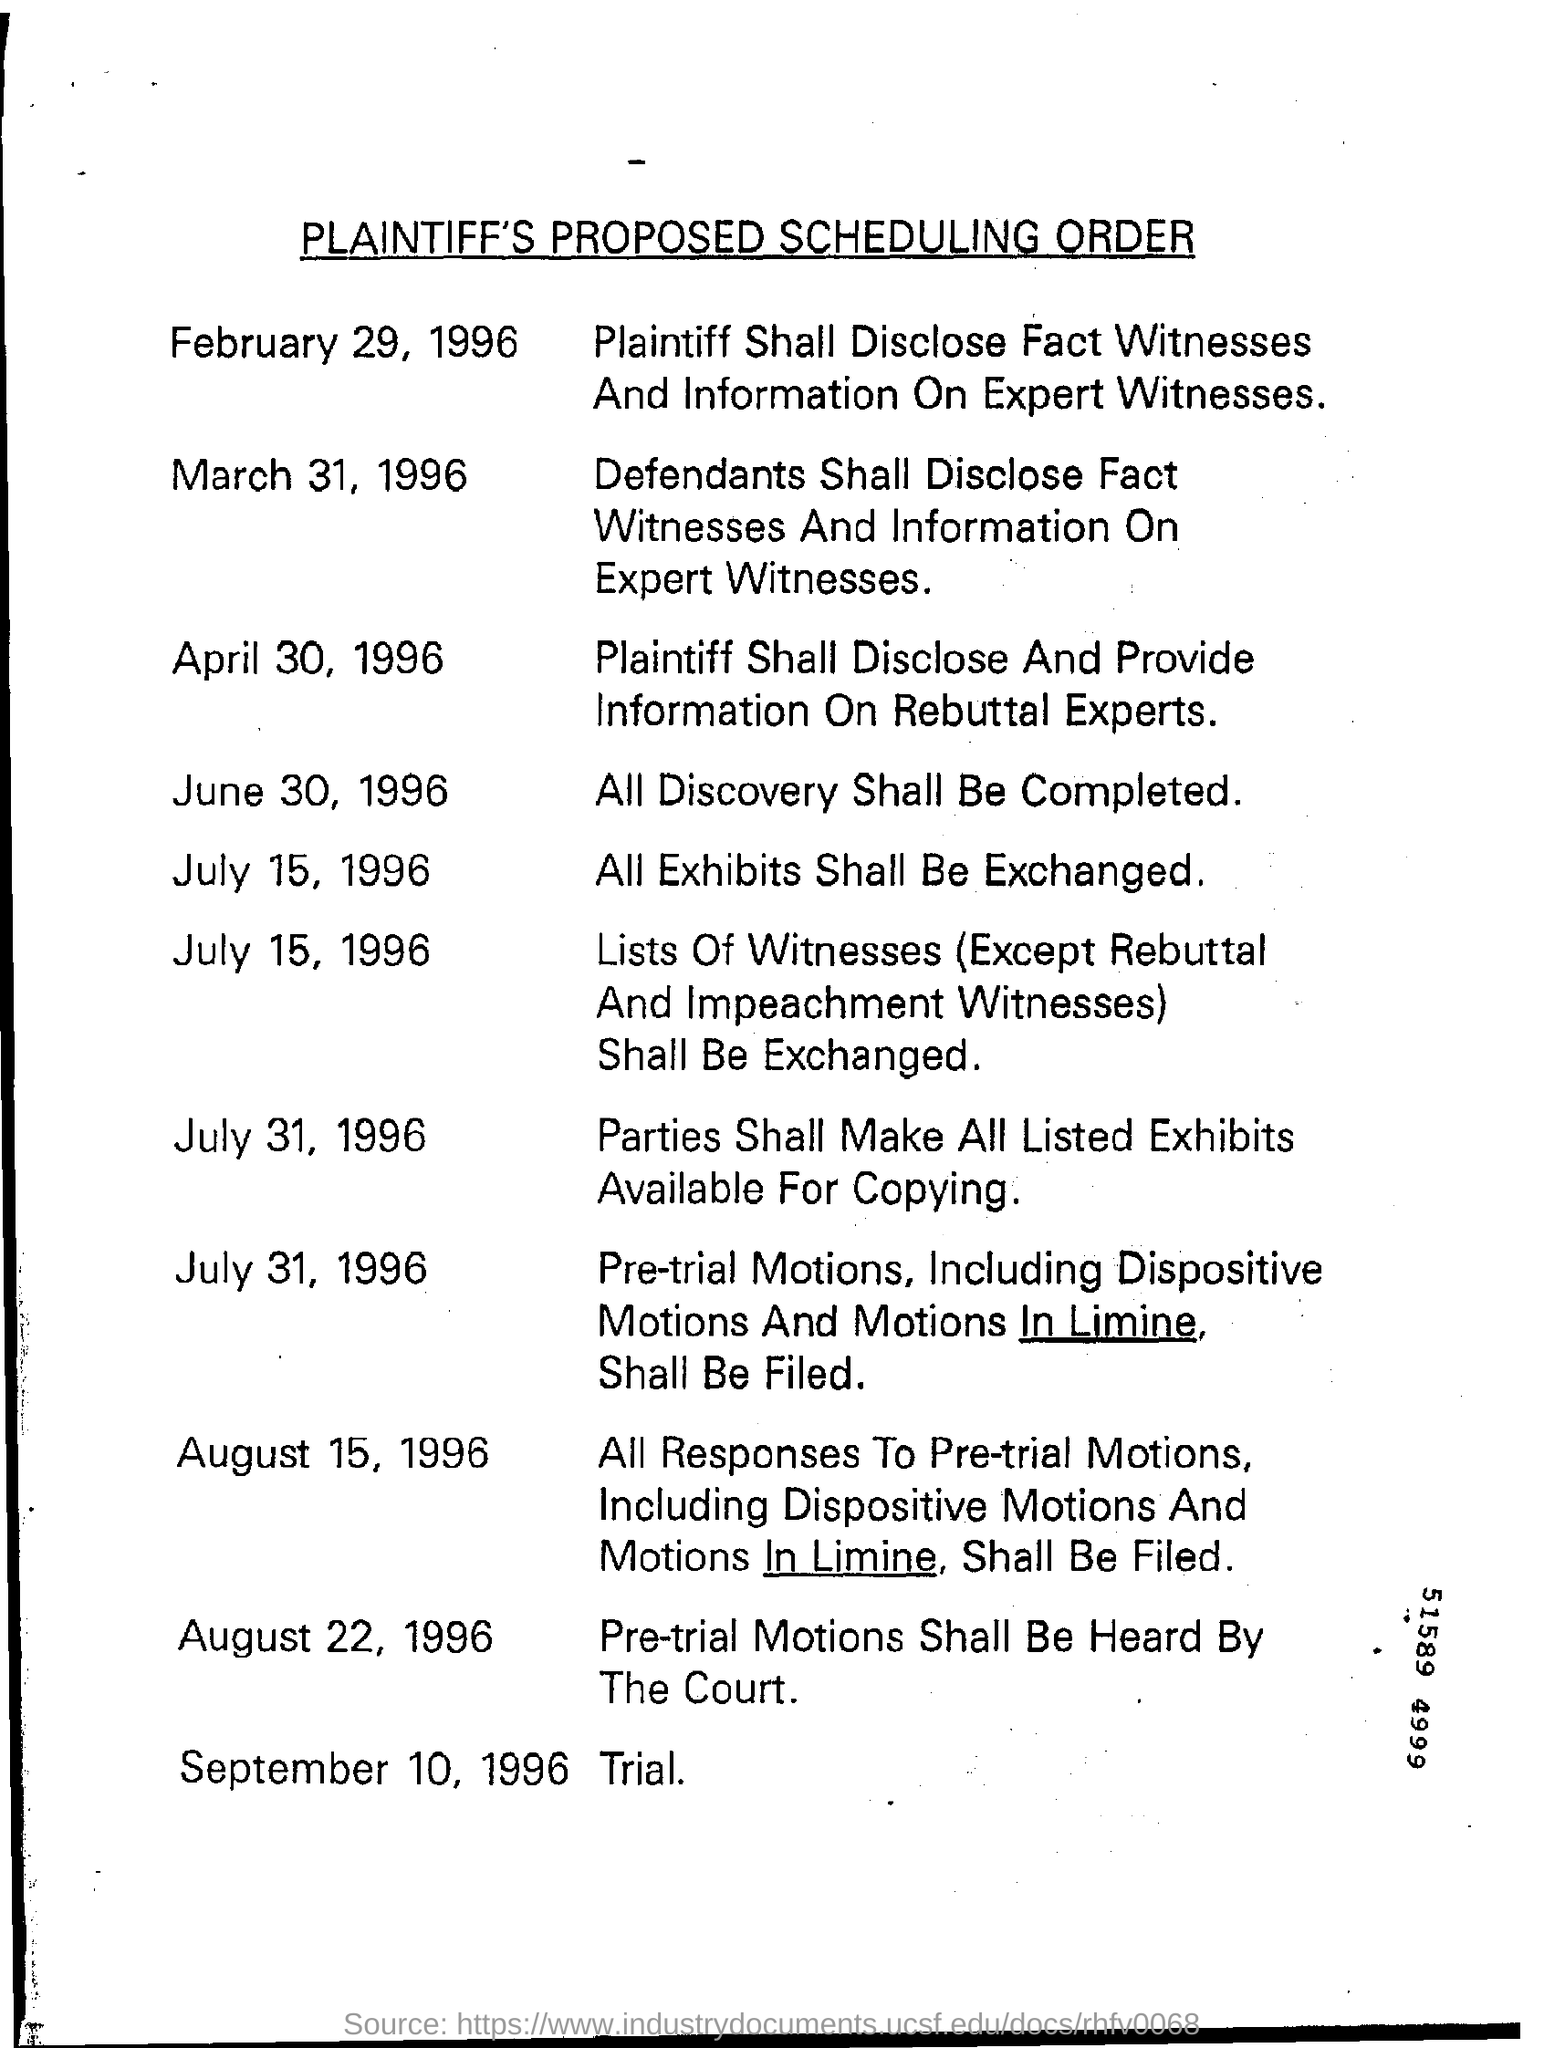What is the heading of the document?
Make the answer very short. PLAINTIFF'S PROPOSED SCHEDULING ORDER. What is scheduled to September 10, 1996?
Offer a very short reply. Trial. On which date shall the parties make all listed exhibits available for copying?
Provide a short and direct response. July 31, 1996. 